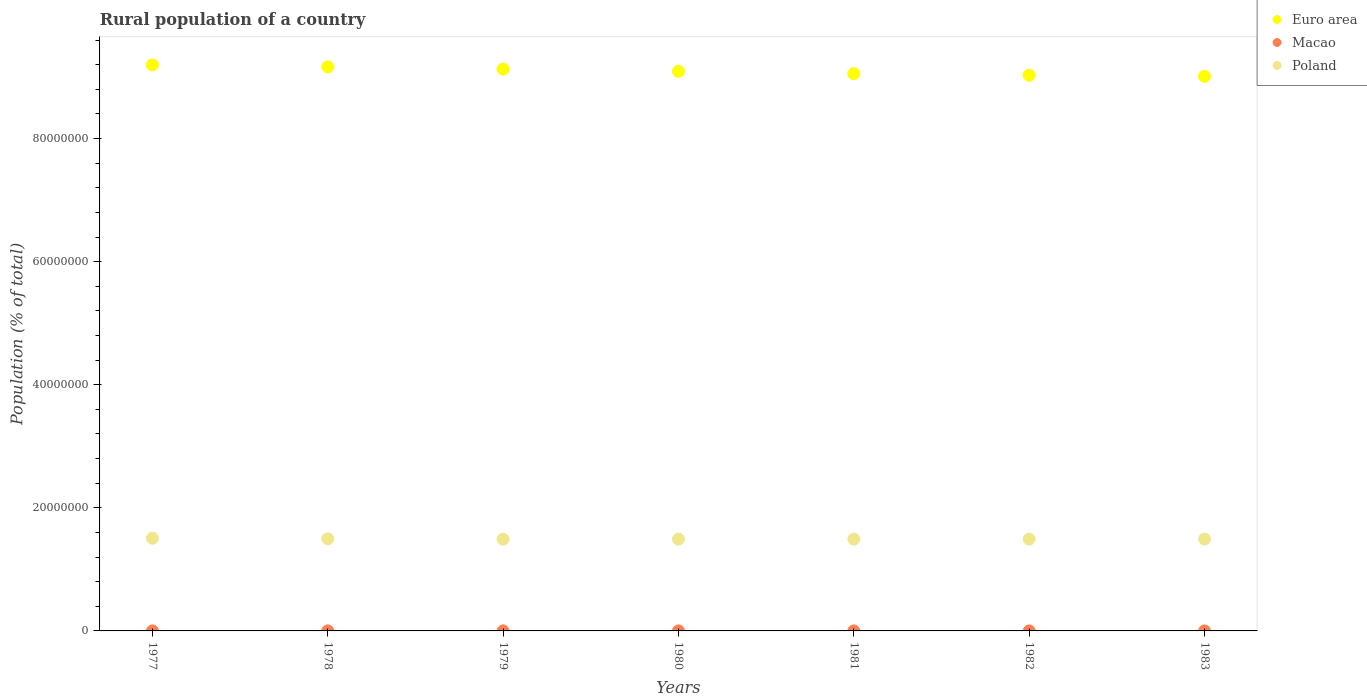How many different coloured dotlines are there?
Offer a terse response. 3. Is the number of dotlines equal to the number of legend labels?
Make the answer very short. Yes. What is the rural population in Macao in 1983?
Your answer should be compact. 2489. Across all years, what is the maximum rural population in Macao?
Offer a terse response. 4463. Across all years, what is the minimum rural population in Euro area?
Keep it short and to the point. 9.01e+07. In which year was the rural population in Poland minimum?
Ensure brevity in your answer.  1979. What is the total rural population in Macao in the graph?
Your response must be concise. 2.49e+04. What is the difference between the rural population in Poland in 1981 and that in 1983?
Offer a very short reply. -7934. What is the difference between the rural population in Poland in 1977 and the rural population in Macao in 1982?
Provide a succinct answer. 1.51e+07. What is the average rural population in Poland per year?
Offer a very short reply. 1.49e+07. In the year 1978, what is the difference between the rural population in Euro area and rural population in Macao?
Offer a very short reply. 9.16e+07. In how many years, is the rural population in Poland greater than 48000000 %?
Provide a succinct answer. 0. What is the ratio of the rural population in Euro area in 1977 to that in 1978?
Ensure brevity in your answer.  1. What is the difference between the highest and the second highest rural population in Poland?
Your answer should be compact. 1.05e+05. What is the difference between the highest and the lowest rural population in Euro area?
Offer a very short reply. 1.86e+06. Is it the case that in every year, the sum of the rural population in Poland and rural population in Macao  is greater than the rural population in Euro area?
Your answer should be compact. No. Is the rural population in Euro area strictly less than the rural population in Poland over the years?
Keep it short and to the point. No. How many dotlines are there?
Make the answer very short. 3. What is the difference between two consecutive major ticks on the Y-axis?
Keep it short and to the point. 2.00e+07. Does the graph contain any zero values?
Provide a short and direct response. No. Where does the legend appear in the graph?
Provide a short and direct response. Top right. How many legend labels are there?
Keep it short and to the point. 3. What is the title of the graph?
Provide a succinct answer. Rural population of a country. What is the label or title of the X-axis?
Ensure brevity in your answer.  Years. What is the label or title of the Y-axis?
Offer a very short reply. Population (% of total). What is the Population (% of total) of Euro area in 1977?
Offer a very short reply. 9.20e+07. What is the Population (% of total) of Macao in 1977?
Your answer should be very brief. 4463. What is the Population (% of total) in Poland in 1977?
Your response must be concise. 1.51e+07. What is the Population (% of total) in Euro area in 1978?
Provide a succinct answer. 9.16e+07. What is the Population (% of total) in Macao in 1978?
Provide a succinct answer. 4136. What is the Population (% of total) of Poland in 1978?
Keep it short and to the point. 1.50e+07. What is the Population (% of total) in Euro area in 1979?
Make the answer very short. 9.13e+07. What is the Population (% of total) in Macao in 1979?
Offer a terse response. 3865. What is the Population (% of total) in Poland in 1979?
Your answer should be compact. 1.49e+07. What is the Population (% of total) of Euro area in 1980?
Give a very brief answer. 9.09e+07. What is the Population (% of total) of Macao in 1980?
Give a very brief answer. 3647. What is the Population (% of total) in Poland in 1980?
Keep it short and to the point. 1.49e+07. What is the Population (% of total) in Euro area in 1981?
Your answer should be compact. 9.05e+07. What is the Population (% of total) in Macao in 1981?
Ensure brevity in your answer.  3393. What is the Population (% of total) in Poland in 1981?
Your answer should be very brief. 1.49e+07. What is the Population (% of total) in Euro area in 1982?
Provide a short and direct response. 9.03e+07. What is the Population (% of total) of Macao in 1982?
Make the answer very short. 2899. What is the Population (% of total) of Poland in 1982?
Provide a short and direct response. 1.49e+07. What is the Population (% of total) in Euro area in 1983?
Give a very brief answer. 9.01e+07. What is the Population (% of total) in Macao in 1983?
Provide a succinct answer. 2489. What is the Population (% of total) of Poland in 1983?
Keep it short and to the point. 1.49e+07. Across all years, what is the maximum Population (% of total) of Euro area?
Your response must be concise. 9.20e+07. Across all years, what is the maximum Population (% of total) of Macao?
Your answer should be very brief. 4463. Across all years, what is the maximum Population (% of total) of Poland?
Ensure brevity in your answer.  1.51e+07. Across all years, what is the minimum Population (% of total) in Euro area?
Make the answer very short. 9.01e+07. Across all years, what is the minimum Population (% of total) of Macao?
Provide a succinct answer. 2489. Across all years, what is the minimum Population (% of total) in Poland?
Offer a very short reply. 1.49e+07. What is the total Population (% of total) of Euro area in the graph?
Provide a short and direct response. 6.37e+08. What is the total Population (% of total) in Macao in the graph?
Ensure brevity in your answer.  2.49e+04. What is the total Population (% of total) in Poland in the graph?
Your response must be concise. 1.05e+08. What is the difference between the Population (% of total) of Euro area in 1977 and that in 1978?
Your answer should be compact. 3.27e+05. What is the difference between the Population (% of total) in Macao in 1977 and that in 1978?
Ensure brevity in your answer.  327. What is the difference between the Population (% of total) of Poland in 1977 and that in 1978?
Your answer should be very brief. 1.05e+05. What is the difference between the Population (% of total) in Euro area in 1977 and that in 1979?
Make the answer very short. 6.90e+05. What is the difference between the Population (% of total) in Macao in 1977 and that in 1979?
Your answer should be compact. 598. What is the difference between the Population (% of total) in Poland in 1977 and that in 1979?
Make the answer very short. 1.58e+05. What is the difference between the Population (% of total) of Euro area in 1977 and that in 1980?
Give a very brief answer. 1.05e+06. What is the difference between the Population (% of total) of Macao in 1977 and that in 1980?
Make the answer very short. 816. What is the difference between the Population (% of total) of Poland in 1977 and that in 1980?
Keep it short and to the point. 1.53e+05. What is the difference between the Population (% of total) in Euro area in 1977 and that in 1981?
Offer a terse response. 1.42e+06. What is the difference between the Population (% of total) of Macao in 1977 and that in 1981?
Offer a very short reply. 1070. What is the difference between the Population (% of total) in Poland in 1977 and that in 1981?
Your response must be concise. 1.51e+05. What is the difference between the Population (% of total) of Euro area in 1977 and that in 1982?
Your answer should be very brief. 1.68e+06. What is the difference between the Population (% of total) in Macao in 1977 and that in 1982?
Provide a short and direct response. 1564. What is the difference between the Population (% of total) of Poland in 1977 and that in 1982?
Offer a terse response. 1.48e+05. What is the difference between the Population (% of total) in Euro area in 1977 and that in 1983?
Offer a very short reply. 1.86e+06. What is the difference between the Population (% of total) of Macao in 1977 and that in 1983?
Provide a succinct answer. 1974. What is the difference between the Population (% of total) in Poland in 1977 and that in 1983?
Your response must be concise. 1.43e+05. What is the difference between the Population (% of total) of Euro area in 1978 and that in 1979?
Make the answer very short. 3.63e+05. What is the difference between the Population (% of total) in Macao in 1978 and that in 1979?
Provide a short and direct response. 271. What is the difference between the Population (% of total) in Poland in 1978 and that in 1979?
Offer a terse response. 5.29e+04. What is the difference between the Population (% of total) of Euro area in 1978 and that in 1980?
Offer a very short reply. 7.21e+05. What is the difference between the Population (% of total) of Macao in 1978 and that in 1980?
Your answer should be compact. 489. What is the difference between the Population (% of total) of Poland in 1978 and that in 1980?
Your answer should be compact. 4.77e+04. What is the difference between the Population (% of total) of Euro area in 1978 and that in 1981?
Offer a very short reply. 1.10e+06. What is the difference between the Population (% of total) in Macao in 1978 and that in 1981?
Your answer should be compact. 743. What is the difference between the Population (% of total) of Poland in 1978 and that in 1981?
Your answer should be very brief. 4.57e+04. What is the difference between the Population (% of total) of Euro area in 1978 and that in 1982?
Give a very brief answer. 1.36e+06. What is the difference between the Population (% of total) of Macao in 1978 and that in 1982?
Provide a succinct answer. 1237. What is the difference between the Population (% of total) in Poland in 1978 and that in 1982?
Your answer should be very brief. 4.26e+04. What is the difference between the Population (% of total) of Euro area in 1978 and that in 1983?
Make the answer very short. 1.53e+06. What is the difference between the Population (% of total) of Macao in 1978 and that in 1983?
Ensure brevity in your answer.  1647. What is the difference between the Population (% of total) in Poland in 1978 and that in 1983?
Make the answer very short. 3.77e+04. What is the difference between the Population (% of total) in Euro area in 1979 and that in 1980?
Keep it short and to the point. 3.58e+05. What is the difference between the Population (% of total) in Macao in 1979 and that in 1980?
Your response must be concise. 218. What is the difference between the Population (% of total) of Poland in 1979 and that in 1980?
Your response must be concise. -5206. What is the difference between the Population (% of total) in Euro area in 1979 and that in 1981?
Make the answer very short. 7.33e+05. What is the difference between the Population (% of total) of Macao in 1979 and that in 1981?
Your answer should be very brief. 472. What is the difference between the Population (% of total) of Poland in 1979 and that in 1981?
Keep it short and to the point. -7289. What is the difference between the Population (% of total) of Euro area in 1979 and that in 1982?
Ensure brevity in your answer.  9.93e+05. What is the difference between the Population (% of total) in Macao in 1979 and that in 1982?
Make the answer very short. 966. What is the difference between the Population (% of total) in Poland in 1979 and that in 1982?
Your response must be concise. -1.04e+04. What is the difference between the Population (% of total) in Euro area in 1979 and that in 1983?
Give a very brief answer. 1.17e+06. What is the difference between the Population (% of total) in Macao in 1979 and that in 1983?
Ensure brevity in your answer.  1376. What is the difference between the Population (% of total) in Poland in 1979 and that in 1983?
Your answer should be compact. -1.52e+04. What is the difference between the Population (% of total) in Euro area in 1980 and that in 1981?
Your response must be concise. 3.75e+05. What is the difference between the Population (% of total) in Macao in 1980 and that in 1981?
Make the answer very short. 254. What is the difference between the Population (% of total) in Poland in 1980 and that in 1981?
Your answer should be compact. -2083. What is the difference between the Population (% of total) of Euro area in 1980 and that in 1982?
Ensure brevity in your answer.  6.35e+05. What is the difference between the Population (% of total) in Macao in 1980 and that in 1982?
Give a very brief answer. 748. What is the difference between the Population (% of total) of Poland in 1980 and that in 1982?
Offer a terse response. -5178. What is the difference between the Population (% of total) of Euro area in 1980 and that in 1983?
Your answer should be very brief. 8.12e+05. What is the difference between the Population (% of total) in Macao in 1980 and that in 1983?
Offer a terse response. 1158. What is the difference between the Population (% of total) in Poland in 1980 and that in 1983?
Ensure brevity in your answer.  -1.00e+04. What is the difference between the Population (% of total) in Euro area in 1981 and that in 1982?
Provide a succinct answer. 2.60e+05. What is the difference between the Population (% of total) in Macao in 1981 and that in 1982?
Give a very brief answer. 494. What is the difference between the Population (% of total) in Poland in 1981 and that in 1982?
Keep it short and to the point. -3095. What is the difference between the Population (% of total) of Euro area in 1981 and that in 1983?
Offer a terse response. 4.37e+05. What is the difference between the Population (% of total) in Macao in 1981 and that in 1983?
Your answer should be very brief. 904. What is the difference between the Population (% of total) of Poland in 1981 and that in 1983?
Your response must be concise. -7934. What is the difference between the Population (% of total) in Euro area in 1982 and that in 1983?
Ensure brevity in your answer.  1.77e+05. What is the difference between the Population (% of total) of Macao in 1982 and that in 1983?
Offer a terse response. 410. What is the difference between the Population (% of total) in Poland in 1982 and that in 1983?
Offer a very short reply. -4839. What is the difference between the Population (% of total) of Euro area in 1977 and the Population (% of total) of Macao in 1978?
Ensure brevity in your answer.  9.20e+07. What is the difference between the Population (% of total) in Euro area in 1977 and the Population (% of total) in Poland in 1978?
Ensure brevity in your answer.  7.70e+07. What is the difference between the Population (% of total) in Macao in 1977 and the Population (% of total) in Poland in 1978?
Make the answer very short. -1.50e+07. What is the difference between the Population (% of total) in Euro area in 1977 and the Population (% of total) in Macao in 1979?
Offer a terse response. 9.20e+07. What is the difference between the Population (% of total) of Euro area in 1977 and the Population (% of total) of Poland in 1979?
Ensure brevity in your answer.  7.71e+07. What is the difference between the Population (% of total) of Macao in 1977 and the Population (% of total) of Poland in 1979?
Make the answer very short. -1.49e+07. What is the difference between the Population (% of total) of Euro area in 1977 and the Population (% of total) of Macao in 1980?
Make the answer very short. 9.20e+07. What is the difference between the Population (% of total) of Euro area in 1977 and the Population (% of total) of Poland in 1980?
Provide a succinct answer. 7.71e+07. What is the difference between the Population (% of total) of Macao in 1977 and the Population (% of total) of Poland in 1980?
Provide a short and direct response. -1.49e+07. What is the difference between the Population (% of total) in Euro area in 1977 and the Population (% of total) in Macao in 1981?
Give a very brief answer. 9.20e+07. What is the difference between the Population (% of total) in Euro area in 1977 and the Population (% of total) in Poland in 1981?
Your answer should be compact. 7.71e+07. What is the difference between the Population (% of total) of Macao in 1977 and the Population (% of total) of Poland in 1981?
Offer a terse response. -1.49e+07. What is the difference between the Population (% of total) in Euro area in 1977 and the Population (% of total) in Macao in 1982?
Offer a very short reply. 9.20e+07. What is the difference between the Population (% of total) in Euro area in 1977 and the Population (% of total) in Poland in 1982?
Provide a succinct answer. 7.71e+07. What is the difference between the Population (% of total) in Macao in 1977 and the Population (% of total) in Poland in 1982?
Keep it short and to the point. -1.49e+07. What is the difference between the Population (% of total) in Euro area in 1977 and the Population (% of total) in Macao in 1983?
Make the answer very short. 9.20e+07. What is the difference between the Population (% of total) of Euro area in 1977 and the Population (% of total) of Poland in 1983?
Your answer should be very brief. 7.70e+07. What is the difference between the Population (% of total) in Macao in 1977 and the Population (% of total) in Poland in 1983?
Your answer should be very brief. -1.49e+07. What is the difference between the Population (% of total) in Euro area in 1978 and the Population (% of total) in Macao in 1979?
Your answer should be compact. 9.16e+07. What is the difference between the Population (% of total) in Euro area in 1978 and the Population (% of total) in Poland in 1979?
Your answer should be very brief. 7.67e+07. What is the difference between the Population (% of total) in Macao in 1978 and the Population (% of total) in Poland in 1979?
Make the answer very short. -1.49e+07. What is the difference between the Population (% of total) of Euro area in 1978 and the Population (% of total) of Macao in 1980?
Your answer should be very brief. 9.16e+07. What is the difference between the Population (% of total) in Euro area in 1978 and the Population (% of total) in Poland in 1980?
Provide a short and direct response. 7.67e+07. What is the difference between the Population (% of total) of Macao in 1978 and the Population (% of total) of Poland in 1980?
Offer a very short reply. -1.49e+07. What is the difference between the Population (% of total) in Euro area in 1978 and the Population (% of total) in Macao in 1981?
Your answer should be very brief. 9.16e+07. What is the difference between the Population (% of total) in Euro area in 1978 and the Population (% of total) in Poland in 1981?
Make the answer very short. 7.67e+07. What is the difference between the Population (% of total) in Macao in 1978 and the Population (% of total) in Poland in 1981?
Keep it short and to the point. -1.49e+07. What is the difference between the Population (% of total) of Euro area in 1978 and the Population (% of total) of Macao in 1982?
Make the answer very short. 9.16e+07. What is the difference between the Population (% of total) of Euro area in 1978 and the Population (% of total) of Poland in 1982?
Keep it short and to the point. 7.67e+07. What is the difference between the Population (% of total) of Macao in 1978 and the Population (% of total) of Poland in 1982?
Offer a terse response. -1.49e+07. What is the difference between the Population (% of total) in Euro area in 1978 and the Population (% of total) in Macao in 1983?
Your answer should be very brief. 9.16e+07. What is the difference between the Population (% of total) of Euro area in 1978 and the Population (% of total) of Poland in 1983?
Make the answer very short. 7.67e+07. What is the difference between the Population (% of total) in Macao in 1978 and the Population (% of total) in Poland in 1983?
Provide a succinct answer. -1.49e+07. What is the difference between the Population (% of total) of Euro area in 1979 and the Population (% of total) of Macao in 1980?
Offer a terse response. 9.13e+07. What is the difference between the Population (% of total) of Euro area in 1979 and the Population (% of total) of Poland in 1980?
Ensure brevity in your answer.  7.64e+07. What is the difference between the Population (% of total) of Macao in 1979 and the Population (% of total) of Poland in 1980?
Make the answer very short. -1.49e+07. What is the difference between the Population (% of total) in Euro area in 1979 and the Population (% of total) in Macao in 1981?
Provide a succinct answer. 9.13e+07. What is the difference between the Population (% of total) in Euro area in 1979 and the Population (% of total) in Poland in 1981?
Ensure brevity in your answer.  7.64e+07. What is the difference between the Population (% of total) of Macao in 1979 and the Population (% of total) of Poland in 1981?
Ensure brevity in your answer.  -1.49e+07. What is the difference between the Population (% of total) of Euro area in 1979 and the Population (% of total) of Macao in 1982?
Provide a short and direct response. 9.13e+07. What is the difference between the Population (% of total) in Euro area in 1979 and the Population (% of total) in Poland in 1982?
Offer a very short reply. 7.64e+07. What is the difference between the Population (% of total) of Macao in 1979 and the Population (% of total) of Poland in 1982?
Keep it short and to the point. -1.49e+07. What is the difference between the Population (% of total) of Euro area in 1979 and the Population (% of total) of Macao in 1983?
Offer a terse response. 9.13e+07. What is the difference between the Population (% of total) in Euro area in 1979 and the Population (% of total) in Poland in 1983?
Your answer should be compact. 7.64e+07. What is the difference between the Population (% of total) in Macao in 1979 and the Population (% of total) in Poland in 1983?
Offer a very short reply. -1.49e+07. What is the difference between the Population (% of total) in Euro area in 1980 and the Population (% of total) in Macao in 1981?
Give a very brief answer. 9.09e+07. What is the difference between the Population (% of total) of Euro area in 1980 and the Population (% of total) of Poland in 1981?
Provide a short and direct response. 7.60e+07. What is the difference between the Population (% of total) in Macao in 1980 and the Population (% of total) in Poland in 1981?
Offer a very short reply. -1.49e+07. What is the difference between the Population (% of total) of Euro area in 1980 and the Population (% of total) of Macao in 1982?
Provide a succinct answer. 9.09e+07. What is the difference between the Population (% of total) in Euro area in 1980 and the Population (% of total) in Poland in 1982?
Your response must be concise. 7.60e+07. What is the difference between the Population (% of total) in Macao in 1980 and the Population (% of total) in Poland in 1982?
Give a very brief answer. -1.49e+07. What is the difference between the Population (% of total) of Euro area in 1980 and the Population (% of total) of Macao in 1983?
Ensure brevity in your answer.  9.09e+07. What is the difference between the Population (% of total) of Euro area in 1980 and the Population (% of total) of Poland in 1983?
Make the answer very short. 7.60e+07. What is the difference between the Population (% of total) of Macao in 1980 and the Population (% of total) of Poland in 1983?
Your answer should be very brief. -1.49e+07. What is the difference between the Population (% of total) in Euro area in 1981 and the Population (% of total) in Macao in 1982?
Offer a terse response. 9.05e+07. What is the difference between the Population (% of total) in Euro area in 1981 and the Population (% of total) in Poland in 1982?
Provide a short and direct response. 7.56e+07. What is the difference between the Population (% of total) of Macao in 1981 and the Population (% of total) of Poland in 1982?
Make the answer very short. -1.49e+07. What is the difference between the Population (% of total) in Euro area in 1981 and the Population (% of total) in Macao in 1983?
Ensure brevity in your answer.  9.05e+07. What is the difference between the Population (% of total) in Euro area in 1981 and the Population (% of total) in Poland in 1983?
Your answer should be very brief. 7.56e+07. What is the difference between the Population (% of total) of Macao in 1981 and the Population (% of total) of Poland in 1983?
Provide a short and direct response. -1.49e+07. What is the difference between the Population (% of total) in Euro area in 1982 and the Population (% of total) in Macao in 1983?
Your answer should be very brief. 9.03e+07. What is the difference between the Population (% of total) of Euro area in 1982 and the Population (% of total) of Poland in 1983?
Make the answer very short. 7.54e+07. What is the difference between the Population (% of total) of Macao in 1982 and the Population (% of total) of Poland in 1983?
Your response must be concise. -1.49e+07. What is the average Population (% of total) in Euro area per year?
Provide a short and direct response. 9.10e+07. What is the average Population (% of total) of Macao per year?
Your response must be concise. 3556. What is the average Population (% of total) in Poland per year?
Ensure brevity in your answer.  1.49e+07. In the year 1977, what is the difference between the Population (% of total) of Euro area and Population (% of total) of Macao?
Give a very brief answer. 9.20e+07. In the year 1977, what is the difference between the Population (% of total) in Euro area and Population (% of total) in Poland?
Offer a terse response. 7.69e+07. In the year 1977, what is the difference between the Population (% of total) in Macao and Population (% of total) in Poland?
Your answer should be very brief. -1.51e+07. In the year 1978, what is the difference between the Population (% of total) in Euro area and Population (% of total) in Macao?
Your response must be concise. 9.16e+07. In the year 1978, what is the difference between the Population (% of total) of Euro area and Population (% of total) of Poland?
Your answer should be compact. 7.67e+07. In the year 1978, what is the difference between the Population (% of total) of Macao and Population (% of total) of Poland?
Ensure brevity in your answer.  -1.50e+07. In the year 1979, what is the difference between the Population (% of total) of Euro area and Population (% of total) of Macao?
Offer a terse response. 9.13e+07. In the year 1979, what is the difference between the Population (% of total) in Euro area and Population (% of total) in Poland?
Offer a terse response. 7.64e+07. In the year 1979, what is the difference between the Population (% of total) in Macao and Population (% of total) in Poland?
Give a very brief answer. -1.49e+07. In the year 1980, what is the difference between the Population (% of total) in Euro area and Population (% of total) in Macao?
Ensure brevity in your answer.  9.09e+07. In the year 1980, what is the difference between the Population (% of total) in Euro area and Population (% of total) in Poland?
Offer a very short reply. 7.60e+07. In the year 1980, what is the difference between the Population (% of total) in Macao and Population (% of total) in Poland?
Give a very brief answer. -1.49e+07. In the year 1981, what is the difference between the Population (% of total) in Euro area and Population (% of total) in Macao?
Your response must be concise. 9.05e+07. In the year 1981, what is the difference between the Population (% of total) of Euro area and Population (% of total) of Poland?
Keep it short and to the point. 7.56e+07. In the year 1981, what is the difference between the Population (% of total) in Macao and Population (% of total) in Poland?
Your response must be concise. -1.49e+07. In the year 1982, what is the difference between the Population (% of total) of Euro area and Population (% of total) of Macao?
Provide a short and direct response. 9.03e+07. In the year 1982, what is the difference between the Population (% of total) in Euro area and Population (% of total) in Poland?
Your answer should be very brief. 7.54e+07. In the year 1982, what is the difference between the Population (% of total) in Macao and Population (% of total) in Poland?
Your response must be concise. -1.49e+07. In the year 1983, what is the difference between the Population (% of total) in Euro area and Population (% of total) in Macao?
Offer a terse response. 9.01e+07. In the year 1983, what is the difference between the Population (% of total) in Euro area and Population (% of total) in Poland?
Provide a succinct answer. 7.52e+07. In the year 1983, what is the difference between the Population (% of total) of Macao and Population (% of total) of Poland?
Ensure brevity in your answer.  -1.49e+07. What is the ratio of the Population (% of total) in Macao in 1977 to that in 1978?
Your answer should be compact. 1.08. What is the ratio of the Population (% of total) in Poland in 1977 to that in 1978?
Offer a terse response. 1.01. What is the ratio of the Population (% of total) of Euro area in 1977 to that in 1979?
Make the answer very short. 1.01. What is the ratio of the Population (% of total) in Macao in 1977 to that in 1979?
Make the answer very short. 1.15. What is the ratio of the Population (% of total) of Poland in 1977 to that in 1979?
Ensure brevity in your answer.  1.01. What is the ratio of the Population (% of total) in Euro area in 1977 to that in 1980?
Keep it short and to the point. 1.01. What is the ratio of the Population (% of total) in Macao in 1977 to that in 1980?
Ensure brevity in your answer.  1.22. What is the ratio of the Population (% of total) in Poland in 1977 to that in 1980?
Ensure brevity in your answer.  1.01. What is the ratio of the Population (% of total) in Euro area in 1977 to that in 1981?
Your response must be concise. 1.02. What is the ratio of the Population (% of total) of Macao in 1977 to that in 1981?
Keep it short and to the point. 1.32. What is the ratio of the Population (% of total) in Euro area in 1977 to that in 1982?
Provide a succinct answer. 1.02. What is the ratio of the Population (% of total) in Macao in 1977 to that in 1982?
Provide a succinct answer. 1.54. What is the ratio of the Population (% of total) in Poland in 1977 to that in 1982?
Ensure brevity in your answer.  1.01. What is the ratio of the Population (% of total) of Euro area in 1977 to that in 1983?
Your answer should be compact. 1.02. What is the ratio of the Population (% of total) of Macao in 1977 to that in 1983?
Provide a short and direct response. 1.79. What is the ratio of the Population (% of total) of Poland in 1977 to that in 1983?
Give a very brief answer. 1.01. What is the ratio of the Population (% of total) in Macao in 1978 to that in 1979?
Keep it short and to the point. 1.07. What is the ratio of the Population (% of total) of Euro area in 1978 to that in 1980?
Ensure brevity in your answer.  1.01. What is the ratio of the Population (% of total) in Macao in 1978 to that in 1980?
Provide a short and direct response. 1.13. What is the ratio of the Population (% of total) of Poland in 1978 to that in 1980?
Offer a very short reply. 1. What is the ratio of the Population (% of total) of Euro area in 1978 to that in 1981?
Offer a very short reply. 1.01. What is the ratio of the Population (% of total) of Macao in 1978 to that in 1981?
Offer a very short reply. 1.22. What is the ratio of the Population (% of total) in Poland in 1978 to that in 1981?
Provide a short and direct response. 1. What is the ratio of the Population (% of total) in Macao in 1978 to that in 1982?
Ensure brevity in your answer.  1.43. What is the ratio of the Population (% of total) of Euro area in 1978 to that in 1983?
Ensure brevity in your answer.  1.02. What is the ratio of the Population (% of total) in Macao in 1978 to that in 1983?
Provide a succinct answer. 1.66. What is the ratio of the Population (% of total) in Poland in 1978 to that in 1983?
Offer a terse response. 1. What is the ratio of the Population (% of total) in Macao in 1979 to that in 1980?
Provide a succinct answer. 1.06. What is the ratio of the Population (% of total) of Macao in 1979 to that in 1981?
Provide a succinct answer. 1.14. What is the ratio of the Population (% of total) in Macao in 1979 to that in 1982?
Offer a terse response. 1.33. What is the ratio of the Population (% of total) in Euro area in 1979 to that in 1983?
Offer a terse response. 1.01. What is the ratio of the Population (% of total) in Macao in 1979 to that in 1983?
Offer a terse response. 1.55. What is the ratio of the Population (% of total) of Euro area in 1980 to that in 1981?
Provide a short and direct response. 1. What is the ratio of the Population (% of total) in Macao in 1980 to that in 1981?
Make the answer very short. 1.07. What is the ratio of the Population (% of total) in Euro area in 1980 to that in 1982?
Your response must be concise. 1.01. What is the ratio of the Population (% of total) in Macao in 1980 to that in 1982?
Make the answer very short. 1.26. What is the ratio of the Population (% of total) of Poland in 1980 to that in 1982?
Offer a terse response. 1. What is the ratio of the Population (% of total) of Macao in 1980 to that in 1983?
Offer a terse response. 1.47. What is the ratio of the Population (% of total) in Poland in 1980 to that in 1983?
Your answer should be compact. 1. What is the ratio of the Population (% of total) of Macao in 1981 to that in 1982?
Offer a very short reply. 1.17. What is the ratio of the Population (% of total) of Poland in 1981 to that in 1982?
Provide a succinct answer. 1. What is the ratio of the Population (% of total) in Macao in 1981 to that in 1983?
Offer a very short reply. 1.36. What is the ratio of the Population (% of total) in Poland in 1981 to that in 1983?
Your response must be concise. 1. What is the ratio of the Population (% of total) in Euro area in 1982 to that in 1983?
Your answer should be very brief. 1. What is the ratio of the Population (% of total) of Macao in 1982 to that in 1983?
Offer a very short reply. 1.16. What is the difference between the highest and the second highest Population (% of total) in Euro area?
Provide a short and direct response. 3.27e+05. What is the difference between the highest and the second highest Population (% of total) of Macao?
Ensure brevity in your answer.  327. What is the difference between the highest and the second highest Population (% of total) in Poland?
Give a very brief answer. 1.05e+05. What is the difference between the highest and the lowest Population (% of total) of Euro area?
Ensure brevity in your answer.  1.86e+06. What is the difference between the highest and the lowest Population (% of total) of Macao?
Ensure brevity in your answer.  1974. What is the difference between the highest and the lowest Population (% of total) of Poland?
Ensure brevity in your answer.  1.58e+05. 